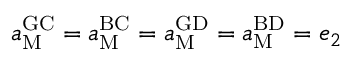<formula> <loc_0><loc_0><loc_500><loc_500>a _ { M } ^ { G C } = a _ { M } ^ { B C } = a _ { M } ^ { G D } = a _ { M } ^ { B D } = e _ { 2 }</formula> 